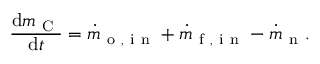Convert formula to latex. <formula><loc_0><loc_0><loc_500><loc_500>\frac { d m _ { C } } { d t } = \dot { m } _ { o , i n } + \dot { m } _ { f , i n } - \dot { m } _ { n } .</formula> 